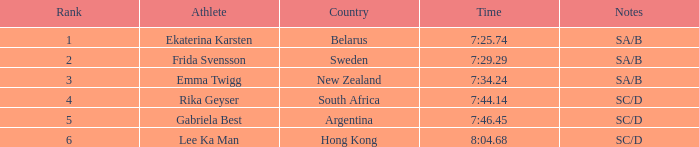Help me parse the entirety of this table. {'header': ['Rank', 'Athlete', 'Country', 'Time', 'Notes'], 'rows': [['1', 'Ekaterina Karsten', 'Belarus', '7:25.74', 'SA/B'], ['2', 'Frida Svensson', 'Sweden', '7:29.29', 'SA/B'], ['3', 'Emma Twigg', 'New Zealand', '7:34.24', 'SA/B'], ['4', 'Rika Geyser', 'South Africa', '7:44.14', 'SC/D'], ['5', 'Gabriela Best', 'Argentina', '7:46.45', 'SC/D'], ['6', 'Lee Ka Man', 'Hong Kong', '8:04.68', 'SC/D']]} 24? 1.0. 